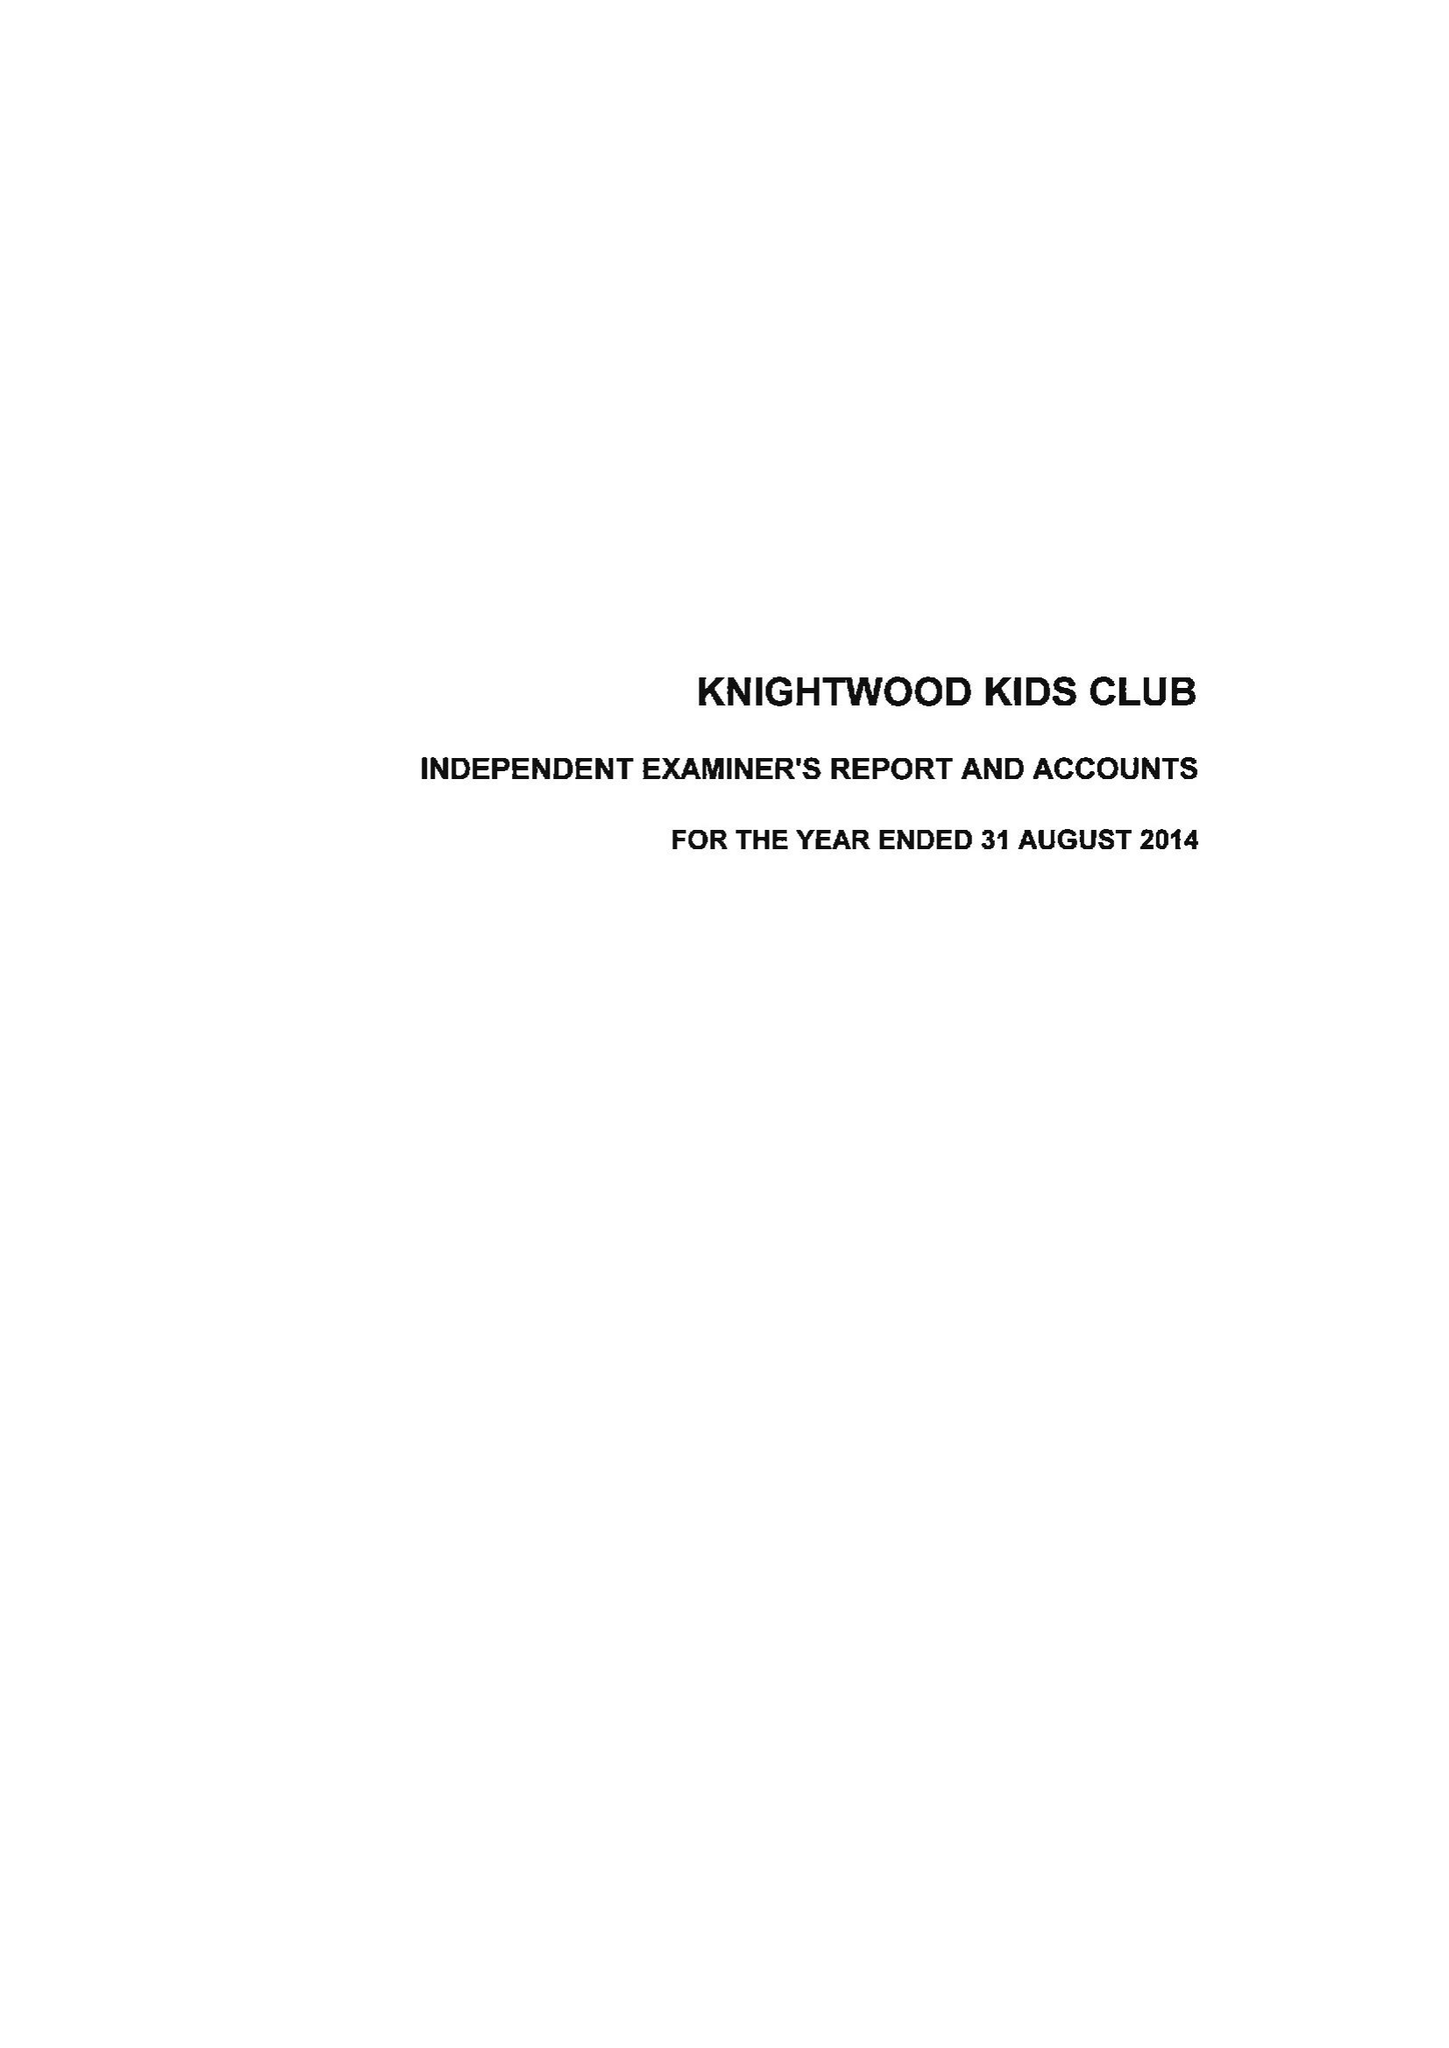What is the value for the charity_number?
Answer the question using a single word or phrase. 1081786 